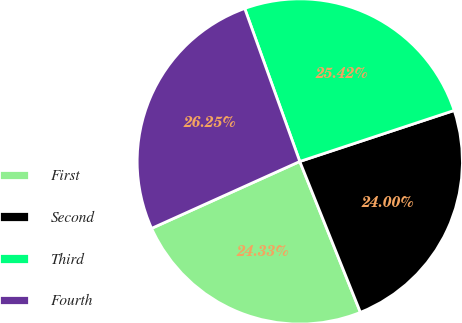Convert chart to OTSL. <chart><loc_0><loc_0><loc_500><loc_500><pie_chart><fcel>First<fcel>Second<fcel>Third<fcel>Fourth<nl><fcel>24.33%<fcel>24.0%<fcel>25.42%<fcel>26.25%<nl></chart> 